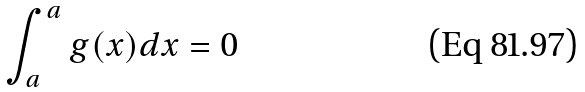<formula> <loc_0><loc_0><loc_500><loc_500>\int _ { a } ^ { a } g ( x ) d x = 0</formula> 